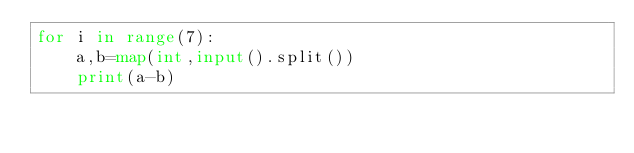<code> <loc_0><loc_0><loc_500><loc_500><_Python_>for i in range(7):
    a,b=map(int,input().split())
    print(a-b)
</code> 